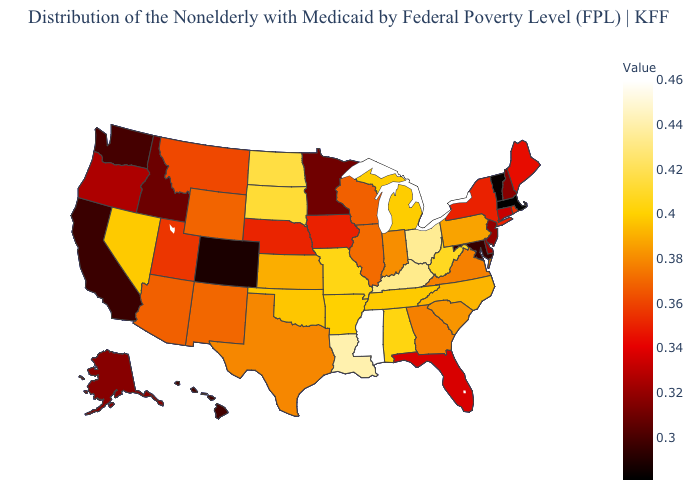Among the states that border Colorado , does Oklahoma have the lowest value?
Give a very brief answer. No. Which states have the highest value in the USA?
Quick response, please. Mississippi. Which states hav the highest value in the MidWest?
Concise answer only. Ohio. Does Ohio have a lower value than Mississippi?
Give a very brief answer. Yes. Does Wisconsin have the highest value in the USA?
Give a very brief answer. No. Which states hav the highest value in the MidWest?
Answer briefly. Ohio. Among the states that border North Dakota , which have the lowest value?
Write a very short answer. Minnesota. 